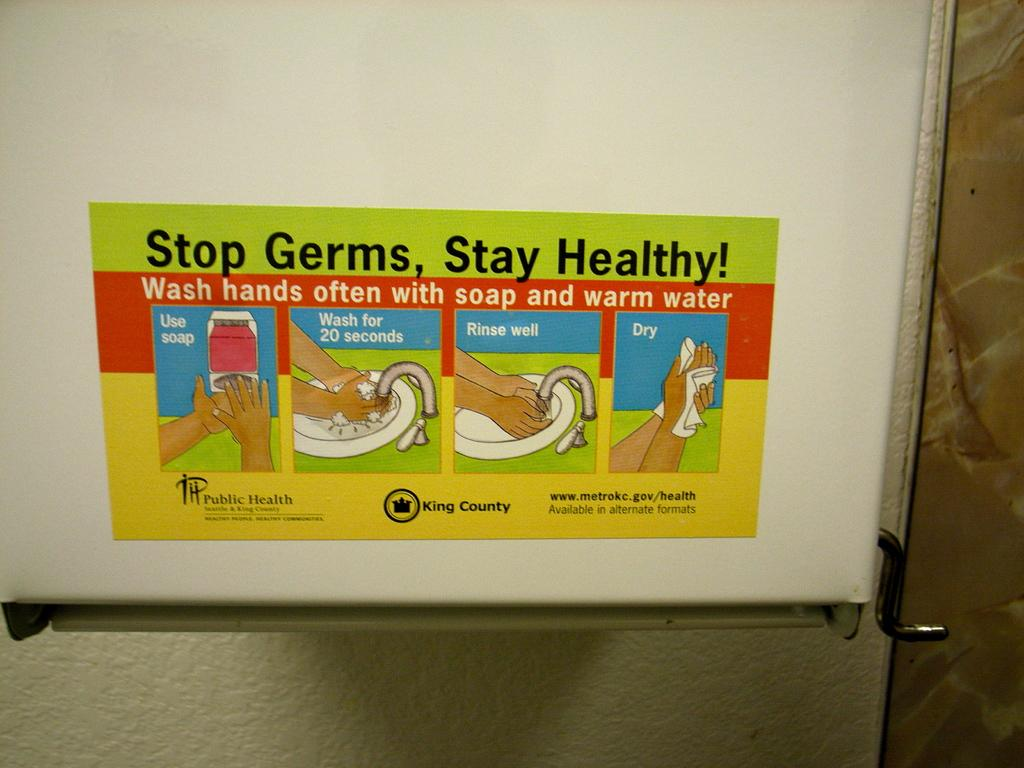<image>
Summarize the visual content of the image. A sign to stop germs and stay heathy by washing your hands. 